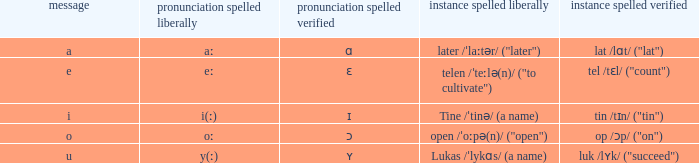How can pronunciation spelled free be defined when pronunciation spelled checked equals "ɛ"? Eː. 